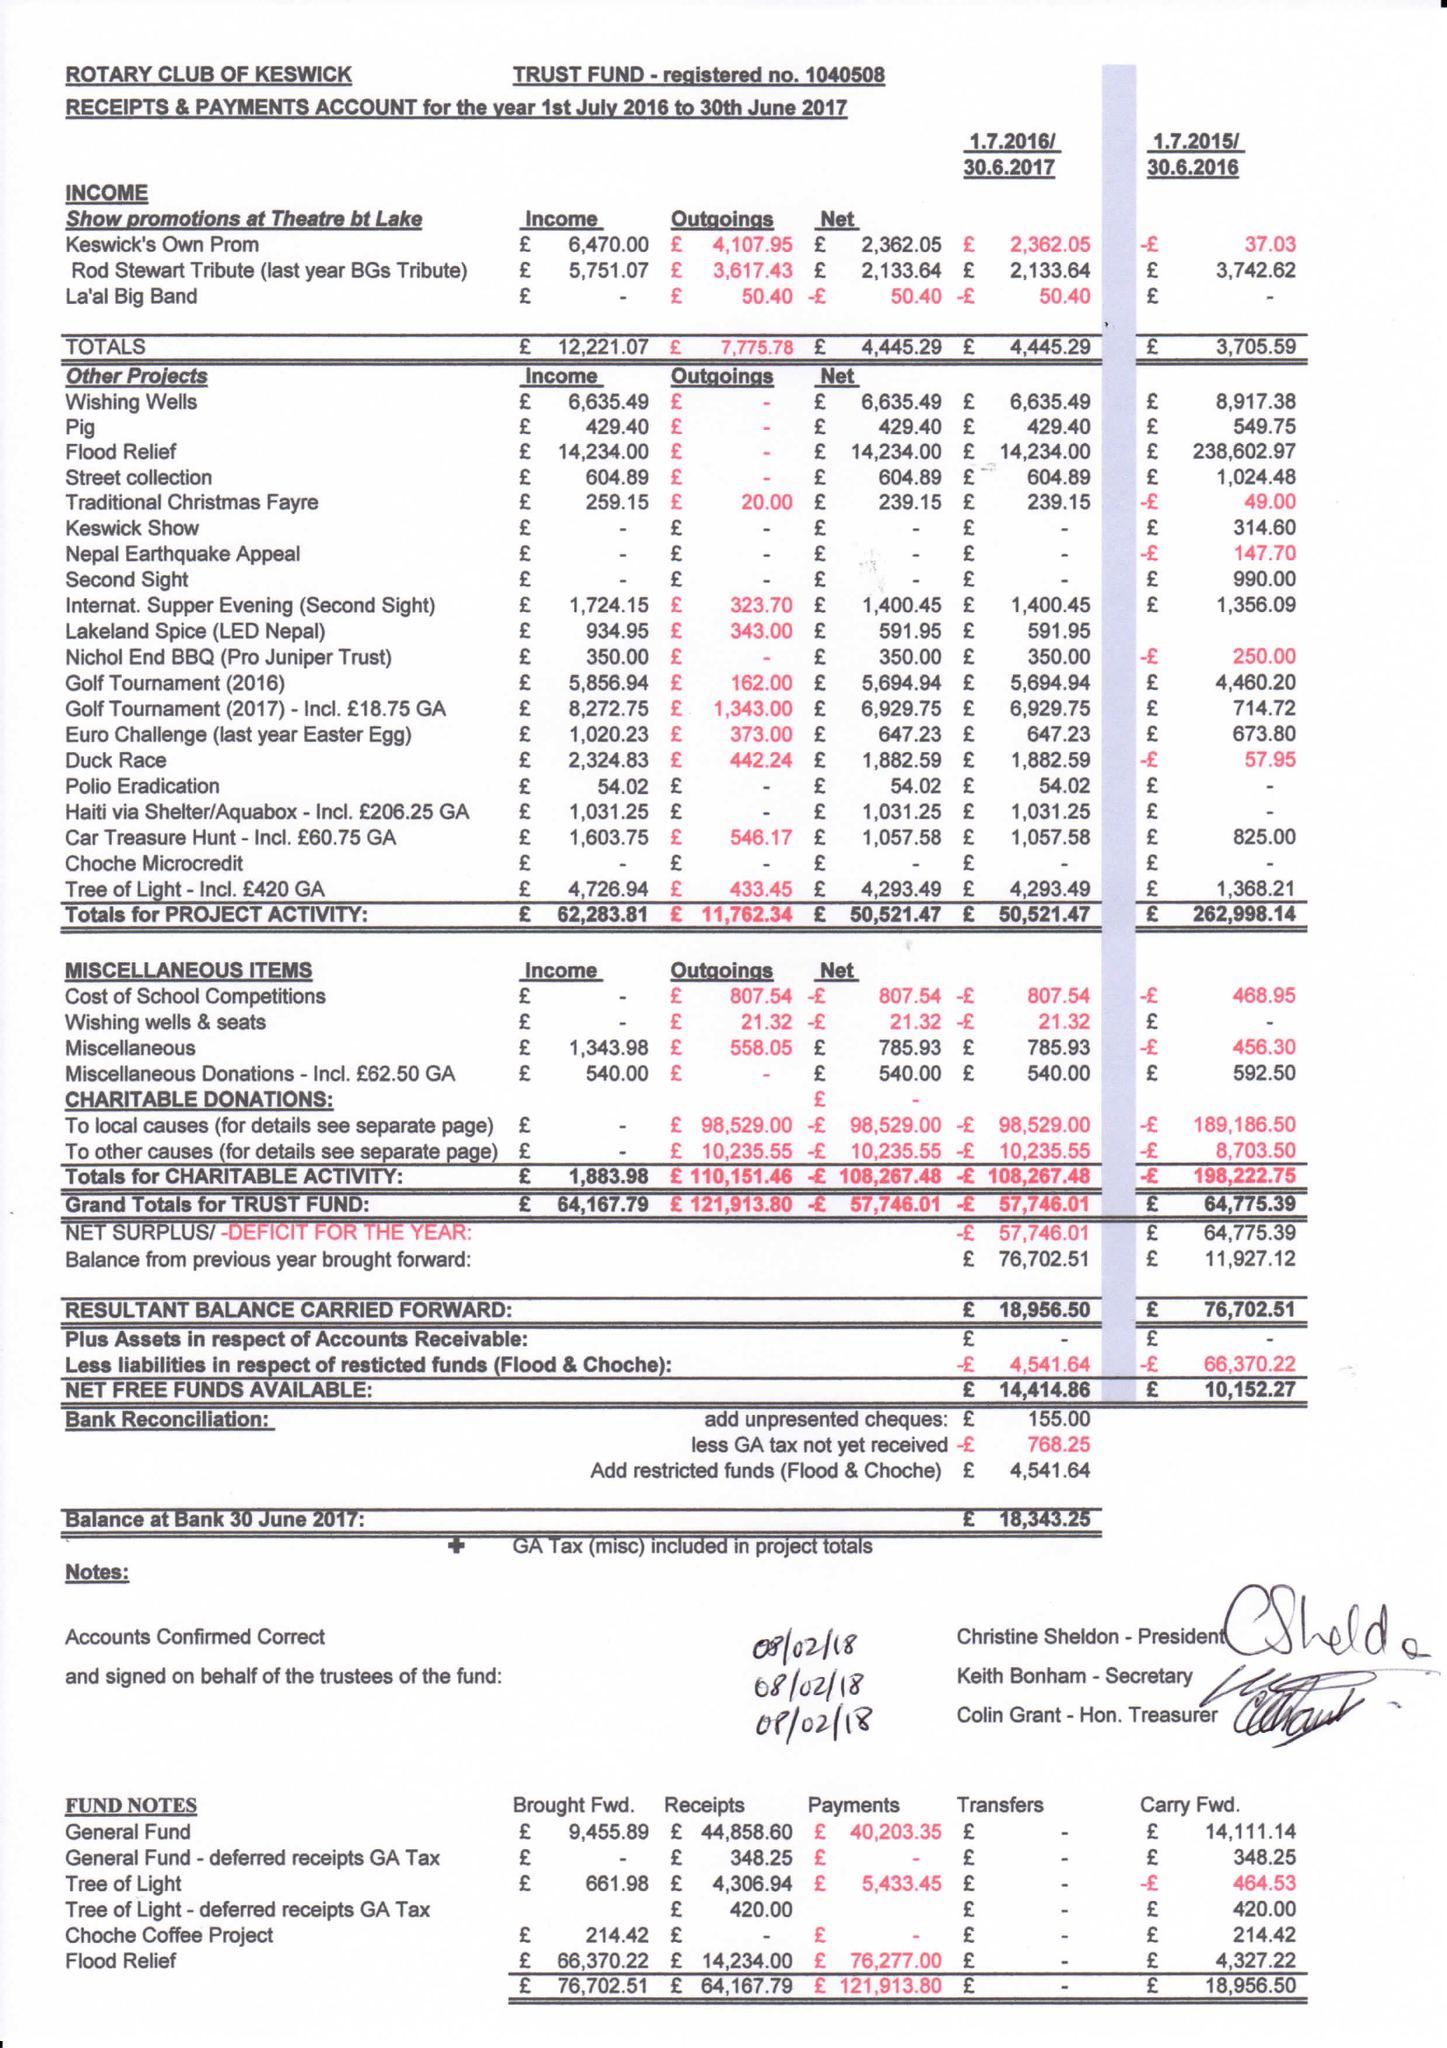What is the value for the spending_annually_in_british_pounds?
Answer the question using a single word or phrase. 121194.00 